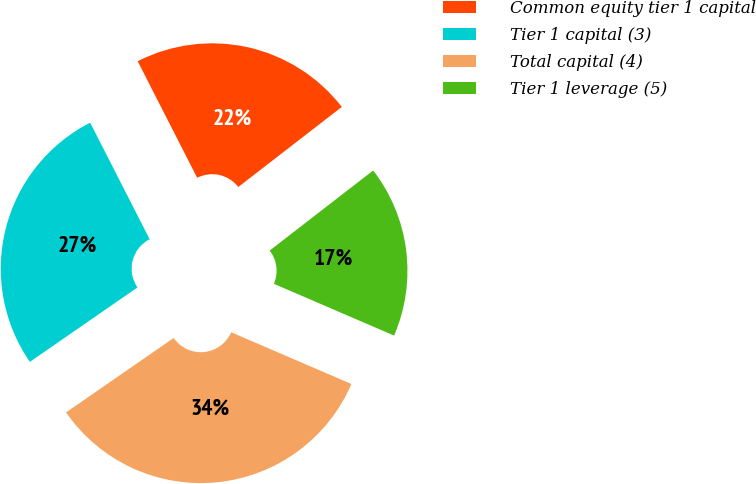Convert chart to OTSL. <chart><loc_0><loc_0><loc_500><loc_500><pie_chart><fcel>Common equity tier 1 capital<fcel>Tier 1 capital (3)<fcel>Total capital (4)<fcel>Tier 1 leverage (5)<nl><fcel>22.03%<fcel>27.12%<fcel>33.9%<fcel>16.95%<nl></chart> 